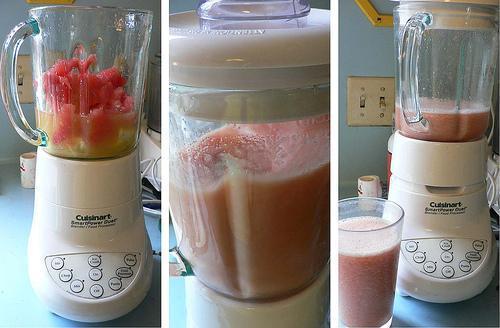How many pictures are here?
Give a very brief answer. 3. 